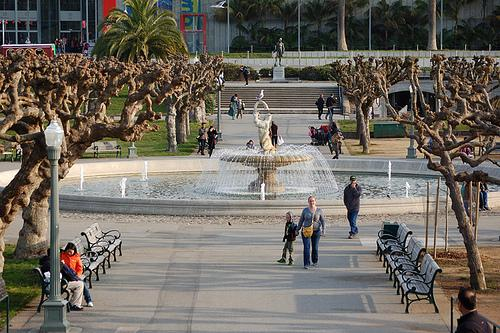In a poetic manner, describe the main activities the people are engaged in. Amidst verdant trees, a mother walks hand in hand with her babe, while quiet conversations fill the air on benches where people find their stay. Comment on the types of trees in the park. Brown and bare trees surround the park, with a few palm trees standing tall near the building. Express the image in a minimalistic way. Park scene: benches, mother and child walking, fountain, and statues. Describe the park's focal point in the image. A large water fountain, adorned with a brown statue, serves as the central attraction amid benches and trees in the park. Provide a brief overview of the main elements in the image. A mother and child walking, people sitting on benches, a man walking alone, a water fountain, statues, and trees are present in the park scene. Narrate an incident in the park as seen in the image. As a mother walks with her son, hand in hand, they pass by a man walking alone and a couple chatting on a nearby bench, all under the canopy of trees. List three items that stand out in the image. A water fountain, an intriguing statue, and a mother and her child walking together. Mention the main activities and objects in the scene as if you're painting a picture with words. Under the gentle shadows of trees, a mother walks with her child, people share whispers on benches, and a grand fountain keeps the time in the picturesque park. Point out an interesting detail about the people in the image. A man walking alone in the park wears a black jacket and blue jeans, with his left hand on his cheek. Describe the atmosphere of the image. The serene park setting invites people to relax, walk or have conversations with loved ones on benches under the watchful gaze of trees and statues. 